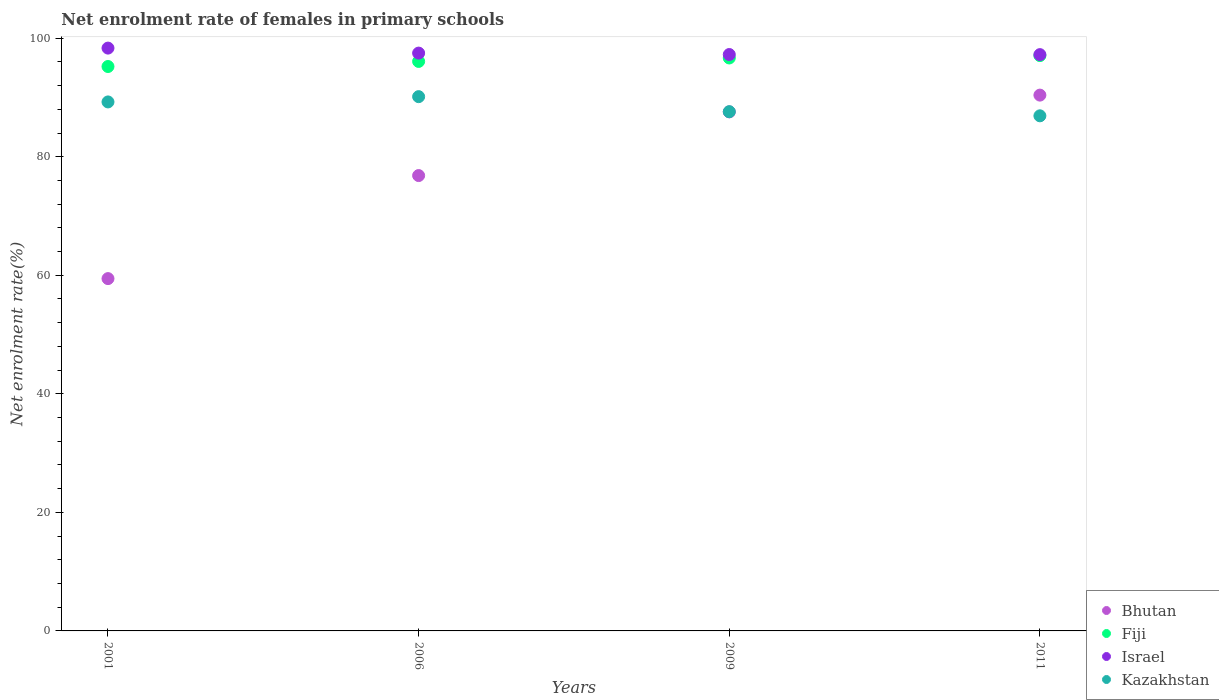Is the number of dotlines equal to the number of legend labels?
Your response must be concise. Yes. What is the net enrolment rate of females in primary schools in Fiji in 2001?
Your answer should be compact. 95.22. Across all years, what is the maximum net enrolment rate of females in primary schools in Israel?
Provide a short and direct response. 98.32. Across all years, what is the minimum net enrolment rate of females in primary schools in Bhutan?
Your answer should be compact. 59.44. In which year was the net enrolment rate of females in primary schools in Fiji maximum?
Offer a very short reply. 2011. In which year was the net enrolment rate of females in primary schools in Kazakhstan minimum?
Offer a very short reply. 2011. What is the total net enrolment rate of females in primary schools in Bhutan in the graph?
Make the answer very short. 314.21. What is the difference between the net enrolment rate of females in primary schools in Israel in 2001 and that in 2011?
Ensure brevity in your answer.  1.1. What is the difference between the net enrolment rate of females in primary schools in Israel in 2006 and the net enrolment rate of females in primary schools in Fiji in 2001?
Offer a very short reply. 2.26. What is the average net enrolment rate of females in primary schools in Bhutan per year?
Your answer should be very brief. 78.55. In the year 2011, what is the difference between the net enrolment rate of females in primary schools in Fiji and net enrolment rate of females in primary schools in Kazakhstan?
Your response must be concise. 10.16. In how many years, is the net enrolment rate of females in primary schools in Bhutan greater than 60 %?
Ensure brevity in your answer.  3. What is the ratio of the net enrolment rate of females in primary schools in Fiji in 2006 to that in 2011?
Your response must be concise. 0.99. Is the net enrolment rate of females in primary schools in Bhutan in 2006 less than that in 2011?
Give a very brief answer. Yes. Is the difference between the net enrolment rate of females in primary schools in Fiji in 2006 and 2011 greater than the difference between the net enrolment rate of females in primary schools in Kazakhstan in 2006 and 2011?
Provide a short and direct response. No. What is the difference between the highest and the second highest net enrolment rate of females in primary schools in Bhutan?
Your response must be concise. 2.83. What is the difference between the highest and the lowest net enrolment rate of females in primary schools in Bhutan?
Make the answer very short. 30.96. In how many years, is the net enrolment rate of females in primary schools in Bhutan greater than the average net enrolment rate of females in primary schools in Bhutan taken over all years?
Your answer should be very brief. 2. Is the sum of the net enrolment rate of females in primary schools in Israel in 2001 and 2009 greater than the maximum net enrolment rate of females in primary schools in Kazakhstan across all years?
Provide a short and direct response. Yes. Is it the case that in every year, the sum of the net enrolment rate of females in primary schools in Bhutan and net enrolment rate of females in primary schools in Kazakhstan  is greater than the sum of net enrolment rate of females in primary schools in Israel and net enrolment rate of females in primary schools in Fiji?
Offer a terse response. No. Is it the case that in every year, the sum of the net enrolment rate of females in primary schools in Bhutan and net enrolment rate of females in primary schools in Israel  is greater than the net enrolment rate of females in primary schools in Kazakhstan?
Keep it short and to the point. Yes. Does the net enrolment rate of females in primary schools in Fiji monotonically increase over the years?
Give a very brief answer. Yes. Is the net enrolment rate of females in primary schools in Kazakhstan strictly greater than the net enrolment rate of females in primary schools in Israel over the years?
Your response must be concise. No. Is the net enrolment rate of females in primary schools in Bhutan strictly less than the net enrolment rate of females in primary schools in Kazakhstan over the years?
Provide a succinct answer. No. What is the difference between two consecutive major ticks on the Y-axis?
Your response must be concise. 20. Are the values on the major ticks of Y-axis written in scientific E-notation?
Your answer should be very brief. No. Does the graph contain any zero values?
Make the answer very short. No. Where does the legend appear in the graph?
Ensure brevity in your answer.  Bottom right. What is the title of the graph?
Provide a short and direct response. Net enrolment rate of females in primary schools. What is the label or title of the Y-axis?
Give a very brief answer. Net enrolment rate(%). What is the Net enrolment rate(%) in Bhutan in 2001?
Your answer should be compact. 59.44. What is the Net enrolment rate(%) in Fiji in 2001?
Give a very brief answer. 95.22. What is the Net enrolment rate(%) of Israel in 2001?
Ensure brevity in your answer.  98.32. What is the Net enrolment rate(%) in Kazakhstan in 2001?
Ensure brevity in your answer.  89.24. What is the Net enrolment rate(%) in Bhutan in 2006?
Your answer should be compact. 76.82. What is the Net enrolment rate(%) of Fiji in 2006?
Ensure brevity in your answer.  96.07. What is the Net enrolment rate(%) of Israel in 2006?
Your response must be concise. 97.48. What is the Net enrolment rate(%) in Kazakhstan in 2006?
Give a very brief answer. 90.13. What is the Net enrolment rate(%) of Bhutan in 2009?
Your answer should be very brief. 87.56. What is the Net enrolment rate(%) in Fiji in 2009?
Your answer should be compact. 96.66. What is the Net enrolment rate(%) in Israel in 2009?
Offer a very short reply. 97.24. What is the Net enrolment rate(%) of Kazakhstan in 2009?
Your response must be concise. 87.6. What is the Net enrolment rate(%) of Bhutan in 2011?
Ensure brevity in your answer.  90.39. What is the Net enrolment rate(%) in Fiji in 2011?
Make the answer very short. 97.06. What is the Net enrolment rate(%) of Israel in 2011?
Offer a terse response. 97.22. What is the Net enrolment rate(%) of Kazakhstan in 2011?
Keep it short and to the point. 86.9. Across all years, what is the maximum Net enrolment rate(%) in Bhutan?
Offer a terse response. 90.39. Across all years, what is the maximum Net enrolment rate(%) in Fiji?
Keep it short and to the point. 97.06. Across all years, what is the maximum Net enrolment rate(%) in Israel?
Give a very brief answer. 98.32. Across all years, what is the maximum Net enrolment rate(%) of Kazakhstan?
Ensure brevity in your answer.  90.13. Across all years, what is the minimum Net enrolment rate(%) in Bhutan?
Your answer should be compact. 59.44. Across all years, what is the minimum Net enrolment rate(%) in Fiji?
Provide a short and direct response. 95.22. Across all years, what is the minimum Net enrolment rate(%) of Israel?
Offer a very short reply. 97.22. Across all years, what is the minimum Net enrolment rate(%) of Kazakhstan?
Ensure brevity in your answer.  86.9. What is the total Net enrolment rate(%) in Bhutan in the graph?
Ensure brevity in your answer.  314.21. What is the total Net enrolment rate(%) in Fiji in the graph?
Your answer should be very brief. 385. What is the total Net enrolment rate(%) of Israel in the graph?
Give a very brief answer. 390.26. What is the total Net enrolment rate(%) of Kazakhstan in the graph?
Provide a succinct answer. 353.87. What is the difference between the Net enrolment rate(%) of Bhutan in 2001 and that in 2006?
Provide a short and direct response. -17.38. What is the difference between the Net enrolment rate(%) of Fiji in 2001 and that in 2006?
Your answer should be compact. -0.86. What is the difference between the Net enrolment rate(%) of Israel in 2001 and that in 2006?
Provide a succinct answer. 0.84. What is the difference between the Net enrolment rate(%) of Kazakhstan in 2001 and that in 2006?
Keep it short and to the point. -0.89. What is the difference between the Net enrolment rate(%) in Bhutan in 2001 and that in 2009?
Give a very brief answer. -28.13. What is the difference between the Net enrolment rate(%) in Fiji in 2001 and that in 2009?
Ensure brevity in your answer.  -1.44. What is the difference between the Net enrolment rate(%) in Israel in 2001 and that in 2009?
Your answer should be very brief. 1.08. What is the difference between the Net enrolment rate(%) of Kazakhstan in 2001 and that in 2009?
Make the answer very short. 1.65. What is the difference between the Net enrolment rate(%) in Bhutan in 2001 and that in 2011?
Your answer should be very brief. -30.96. What is the difference between the Net enrolment rate(%) of Fiji in 2001 and that in 2011?
Ensure brevity in your answer.  -1.84. What is the difference between the Net enrolment rate(%) in Israel in 2001 and that in 2011?
Make the answer very short. 1.1. What is the difference between the Net enrolment rate(%) of Kazakhstan in 2001 and that in 2011?
Your answer should be very brief. 2.34. What is the difference between the Net enrolment rate(%) of Bhutan in 2006 and that in 2009?
Your response must be concise. -10.74. What is the difference between the Net enrolment rate(%) of Fiji in 2006 and that in 2009?
Your response must be concise. -0.58. What is the difference between the Net enrolment rate(%) in Israel in 2006 and that in 2009?
Ensure brevity in your answer.  0.24. What is the difference between the Net enrolment rate(%) in Kazakhstan in 2006 and that in 2009?
Provide a succinct answer. 2.54. What is the difference between the Net enrolment rate(%) in Bhutan in 2006 and that in 2011?
Offer a terse response. -13.57. What is the difference between the Net enrolment rate(%) of Fiji in 2006 and that in 2011?
Give a very brief answer. -0.98. What is the difference between the Net enrolment rate(%) of Israel in 2006 and that in 2011?
Offer a terse response. 0.26. What is the difference between the Net enrolment rate(%) in Kazakhstan in 2006 and that in 2011?
Provide a succinct answer. 3.23. What is the difference between the Net enrolment rate(%) of Bhutan in 2009 and that in 2011?
Your response must be concise. -2.83. What is the difference between the Net enrolment rate(%) in Fiji in 2009 and that in 2011?
Provide a short and direct response. -0.4. What is the difference between the Net enrolment rate(%) of Israel in 2009 and that in 2011?
Offer a very short reply. 0.02. What is the difference between the Net enrolment rate(%) of Kazakhstan in 2009 and that in 2011?
Keep it short and to the point. 0.7. What is the difference between the Net enrolment rate(%) in Bhutan in 2001 and the Net enrolment rate(%) in Fiji in 2006?
Provide a short and direct response. -36.64. What is the difference between the Net enrolment rate(%) of Bhutan in 2001 and the Net enrolment rate(%) of Israel in 2006?
Ensure brevity in your answer.  -38.04. What is the difference between the Net enrolment rate(%) of Bhutan in 2001 and the Net enrolment rate(%) of Kazakhstan in 2006?
Your answer should be compact. -30.7. What is the difference between the Net enrolment rate(%) of Fiji in 2001 and the Net enrolment rate(%) of Israel in 2006?
Give a very brief answer. -2.26. What is the difference between the Net enrolment rate(%) in Fiji in 2001 and the Net enrolment rate(%) in Kazakhstan in 2006?
Give a very brief answer. 5.08. What is the difference between the Net enrolment rate(%) of Israel in 2001 and the Net enrolment rate(%) of Kazakhstan in 2006?
Keep it short and to the point. 8.19. What is the difference between the Net enrolment rate(%) in Bhutan in 2001 and the Net enrolment rate(%) in Fiji in 2009?
Your answer should be compact. -37.22. What is the difference between the Net enrolment rate(%) in Bhutan in 2001 and the Net enrolment rate(%) in Israel in 2009?
Keep it short and to the point. -37.8. What is the difference between the Net enrolment rate(%) of Bhutan in 2001 and the Net enrolment rate(%) of Kazakhstan in 2009?
Ensure brevity in your answer.  -28.16. What is the difference between the Net enrolment rate(%) in Fiji in 2001 and the Net enrolment rate(%) in Israel in 2009?
Offer a terse response. -2.02. What is the difference between the Net enrolment rate(%) of Fiji in 2001 and the Net enrolment rate(%) of Kazakhstan in 2009?
Offer a very short reply. 7.62. What is the difference between the Net enrolment rate(%) of Israel in 2001 and the Net enrolment rate(%) of Kazakhstan in 2009?
Your response must be concise. 10.73. What is the difference between the Net enrolment rate(%) of Bhutan in 2001 and the Net enrolment rate(%) of Fiji in 2011?
Make the answer very short. -37.62. What is the difference between the Net enrolment rate(%) of Bhutan in 2001 and the Net enrolment rate(%) of Israel in 2011?
Ensure brevity in your answer.  -37.79. What is the difference between the Net enrolment rate(%) in Bhutan in 2001 and the Net enrolment rate(%) in Kazakhstan in 2011?
Your answer should be very brief. -27.46. What is the difference between the Net enrolment rate(%) in Fiji in 2001 and the Net enrolment rate(%) in Israel in 2011?
Offer a very short reply. -2.01. What is the difference between the Net enrolment rate(%) of Fiji in 2001 and the Net enrolment rate(%) of Kazakhstan in 2011?
Give a very brief answer. 8.32. What is the difference between the Net enrolment rate(%) of Israel in 2001 and the Net enrolment rate(%) of Kazakhstan in 2011?
Offer a very short reply. 11.42. What is the difference between the Net enrolment rate(%) of Bhutan in 2006 and the Net enrolment rate(%) of Fiji in 2009?
Offer a very short reply. -19.84. What is the difference between the Net enrolment rate(%) of Bhutan in 2006 and the Net enrolment rate(%) of Israel in 2009?
Provide a succinct answer. -20.42. What is the difference between the Net enrolment rate(%) of Bhutan in 2006 and the Net enrolment rate(%) of Kazakhstan in 2009?
Ensure brevity in your answer.  -10.78. What is the difference between the Net enrolment rate(%) of Fiji in 2006 and the Net enrolment rate(%) of Israel in 2009?
Your answer should be very brief. -1.16. What is the difference between the Net enrolment rate(%) of Fiji in 2006 and the Net enrolment rate(%) of Kazakhstan in 2009?
Ensure brevity in your answer.  8.48. What is the difference between the Net enrolment rate(%) in Israel in 2006 and the Net enrolment rate(%) in Kazakhstan in 2009?
Your answer should be compact. 9.88. What is the difference between the Net enrolment rate(%) in Bhutan in 2006 and the Net enrolment rate(%) in Fiji in 2011?
Keep it short and to the point. -20.24. What is the difference between the Net enrolment rate(%) of Bhutan in 2006 and the Net enrolment rate(%) of Israel in 2011?
Provide a succinct answer. -20.4. What is the difference between the Net enrolment rate(%) of Bhutan in 2006 and the Net enrolment rate(%) of Kazakhstan in 2011?
Provide a short and direct response. -10.08. What is the difference between the Net enrolment rate(%) in Fiji in 2006 and the Net enrolment rate(%) in Israel in 2011?
Keep it short and to the point. -1.15. What is the difference between the Net enrolment rate(%) in Fiji in 2006 and the Net enrolment rate(%) in Kazakhstan in 2011?
Your answer should be very brief. 9.18. What is the difference between the Net enrolment rate(%) of Israel in 2006 and the Net enrolment rate(%) of Kazakhstan in 2011?
Your answer should be very brief. 10.58. What is the difference between the Net enrolment rate(%) of Bhutan in 2009 and the Net enrolment rate(%) of Fiji in 2011?
Offer a very short reply. -9.5. What is the difference between the Net enrolment rate(%) in Bhutan in 2009 and the Net enrolment rate(%) in Israel in 2011?
Offer a very short reply. -9.66. What is the difference between the Net enrolment rate(%) of Bhutan in 2009 and the Net enrolment rate(%) of Kazakhstan in 2011?
Offer a terse response. 0.66. What is the difference between the Net enrolment rate(%) of Fiji in 2009 and the Net enrolment rate(%) of Israel in 2011?
Ensure brevity in your answer.  -0.57. What is the difference between the Net enrolment rate(%) of Fiji in 2009 and the Net enrolment rate(%) of Kazakhstan in 2011?
Your answer should be very brief. 9.76. What is the difference between the Net enrolment rate(%) in Israel in 2009 and the Net enrolment rate(%) in Kazakhstan in 2011?
Offer a very short reply. 10.34. What is the average Net enrolment rate(%) of Bhutan per year?
Offer a terse response. 78.55. What is the average Net enrolment rate(%) of Fiji per year?
Offer a terse response. 96.25. What is the average Net enrolment rate(%) in Israel per year?
Your answer should be compact. 97.57. What is the average Net enrolment rate(%) of Kazakhstan per year?
Your answer should be compact. 88.47. In the year 2001, what is the difference between the Net enrolment rate(%) in Bhutan and Net enrolment rate(%) in Fiji?
Make the answer very short. -35.78. In the year 2001, what is the difference between the Net enrolment rate(%) of Bhutan and Net enrolment rate(%) of Israel?
Your answer should be compact. -38.89. In the year 2001, what is the difference between the Net enrolment rate(%) in Bhutan and Net enrolment rate(%) in Kazakhstan?
Keep it short and to the point. -29.81. In the year 2001, what is the difference between the Net enrolment rate(%) in Fiji and Net enrolment rate(%) in Israel?
Give a very brief answer. -3.11. In the year 2001, what is the difference between the Net enrolment rate(%) of Fiji and Net enrolment rate(%) of Kazakhstan?
Give a very brief answer. 5.97. In the year 2001, what is the difference between the Net enrolment rate(%) of Israel and Net enrolment rate(%) of Kazakhstan?
Your answer should be very brief. 9.08. In the year 2006, what is the difference between the Net enrolment rate(%) of Bhutan and Net enrolment rate(%) of Fiji?
Offer a terse response. -19.26. In the year 2006, what is the difference between the Net enrolment rate(%) in Bhutan and Net enrolment rate(%) in Israel?
Ensure brevity in your answer.  -20.66. In the year 2006, what is the difference between the Net enrolment rate(%) of Bhutan and Net enrolment rate(%) of Kazakhstan?
Your answer should be very brief. -13.31. In the year 2006, what is the difference between the Net enrolment rate(%) of Fiji and Net enrolment rate(%) of Israel?
Your answer should be very brief. -1.41. In the year 2006, what is the difference between the Net enrolment rate(%) in Fiji and Net enrolment rate(%) in Kazakhstan?
Your response must be concise. 5.94. In the year 2006, what is the difference between the Net enrolment rate(%) in Israel and Net enrolment rate(%) in Kazakhstan?
Offer a very short reply. 7.35. In the year 2009, what is the difference between the Net enrolment rate(%) of Bhutan and Net enrolment rate(%) of Fiji?
Keep it short and to the point. -9.09. In the year 2009, what is the difference between the Net enrolment rate(%) in Bhutan and Net enrolment rate(%) in Israel?
Ensure brevity in your answer.  -9.68. In the year 2009, what is the difference between the Net enrolment rate(%) of Bhutan and Net enrolment rate(%) of Kazakhstan?
Ensure brevity in your answer.  -0.03. In the year 2009, what is the difference between the Net enrolment rate(%) of Fiji and Net enrolment rate(%) of Israel?
Give a very brief answer. -0.58. In the year 2009, what is the difference between the Net enrolment rate(%) of Fiji and Net enrolment rate(%) of Kazakhstan?
Keep it short and to the point. 9.06. In the year 2009, what is the difference between the Net enrolment rate(%) in Israel and Net enrolment rate(%) in Kazakhstan?
Make the answer very short. 9.64. In the year 2011, what is the difference between the Net enrolment rate(%) of Bhutan and Net enrolment rate(%) of Fiji?
Provide a succinct answer. -6.67. In the year 2011, what is the difference between the Net enrolment rate(%) in Bhutan and Net enrolment rate(%) in Israel?
Offer a very short reply. -6.83. In the year 2011, what is the difference between the Net enrolment rate(%) in Bhutan and Net enrolment rate(%) in Kazakhstan?
Provide a short and direct response. 3.49. In the year 2011, what is the difference between the Net enrolment rate(%) of Fiji and Net enrolment rate(%) of Israel?
Ensure brevity in your answer.  -0.16. In the year 2011, what is the difference between the Net enrolment rate(%) of Fiji and Net enrolment rate(%) of Kazakhstan?
Provide a short and direct response. 10.16. In the year 2011, what is the difference between the Net enrolment rate(%) in Israel and Net enrolment rate(%) in Kazakhstan?
Keep it short and to the point. 10.32. What is the ratio of the Net enrolment rate(%) in Bhutan in 2001 to that in 2006?
Offer a very short reply. 0.77. What is the ratio of the Net enrolment rate(%) in Fiji in 2001 to that in 2006?
Keep it short and to the point. 0.99. What is the ratio of the Net enrolment rate(%) in Israel in 2001 to that in 2006?
Give a very brief answer. 1.01. What is the ratio of the Net enrolment rate(%) of Kazakhstan in 2001 to that in 2006?
Ensure brevity in your answer.  0.99. What is the ratio of the Net enrolment rate(%) of Bhutan in 2001 to that in 2009?
Your answer should be very brief. 0.68. What is the ratio of the Net enrolment rate(%) in Fiji in 2001 to that in 2009?
Give a very brief answer. 0.99. What is the ratio of the Net enrolment rate(%) of Israel in 2001 to that in 2009?
Ensure brevity in your answer.  1.01. What is the ratio of the Net enrolment rate(%) in Kazakhstan in 2001 to that in 2009?
Your answer should be compact. 1.02. What is the ratio of the Net enrolment rate(%) in Bhutan in 2001 to that in 2011?
Offer a terse response. 0.66. What is the ratio of the Net enrolment rate(%) of Fiji in 2001 to that in 2011?
Provide a short and direct response. 0.98. What is the ratio of the Net enrolment rate(%) of Israel in 2001 to that in 2011?
Keep it short and to the point. 1.01. What is the ratio of the Net enrolment rate(%) in Bhutan in 2006 to that in 2009?
Your answer should be compact. 0.88. What is the ratio of the Net enrolment rate(%) of Fiji in 2006 to that in 2009?
Ensure brevity in your answer.  0.99. What is the ratio of the Net enrolment rate(%) in Israel in 2006 to that in 2009?
Your response must be concise. 1. What is the ratio of the Net enrolment rate(%) of Kazakhstan in 2006 to that in 2009?
Offer a very short reply. 1.03. What is the ratio of the Net enrolment rate(%) in Bhutan in 2006 to that in 2011?
Give a very brief answer. 0.85. What is the ratio of the Net enrolment rate(%) of Kazakhstan in 2006 to that in 2011?
Your answer should be compact. 1.04. What is the ratio of the Net enrolment rate(%) in Bhutan in 2009 to that in 2011?
Keep it short and to the point. 0.97. What is the ratio of the Net enrolment rate(%) in Israel in 2009 to that in 2011?
Provide a short and direct response. 1. What is the ratio of the Net enrolment rate(%) in Kazakhstan in 2009 to that in 2011?
Your answer should be very brief. 1.01. What is the difference between the highest and the second highest Net enrolment rate(%) in Bhutan?
Your answer should be very brief. 2.83. What is the difference between the highest and the second highest Net enrolment rate(%) in Fiji?
Provide a short and direct response. 0.4. What is the difference between the highest and the second highest Net enrolment rate(%) of Israel?
Your response must be concise. 0.84. What is the difference between the highest and the second highest Net enrolment rate(%) in Kazakhstan?
Your response must be concise. 0.89. What is the difference between the highest and the lowest Net enrolment rate(%) of Bhutan?
Give a very brief answer. 30.96. What is the difference between the highest and the lowest Net enrolment rate(%) in Fiji?
Offer a terse response. 1.84. What is the difference between the highest and the lowest Net enrolment rate(%) in Israel?
Provide a short and direct response. 1.1. What is the difference between the highest and the lowest Net enrolment rate(%) in Kazakhstan?
Your response must be concise. 3.23. 